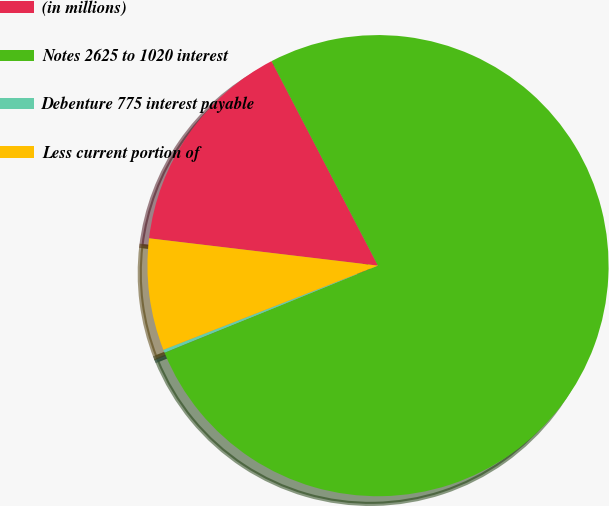<chart> <loc_0><loc_0><loc_500><loc_500><pie_chart><fcel>(in millions)<fcel>Notes 2625 to 1020 interest<fcel>Debenture 775 interest payable<fcel>Less current portion of<nl><fcel>15.47%<fcel>76.47%<fcel>0.22%<fcel>7.84%<nl></chart> 